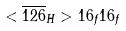Convert formula to latex. <formula><loc_0><loc_0><loc_500><loc_500>< \overline { 1 2 6 } _ { H } > 1 6 _ { f } 1 6 _ { f }</formula> 